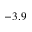<formula> <loc_0><loc_0><loc_500><loc_500>- 3 . 9</formula> 